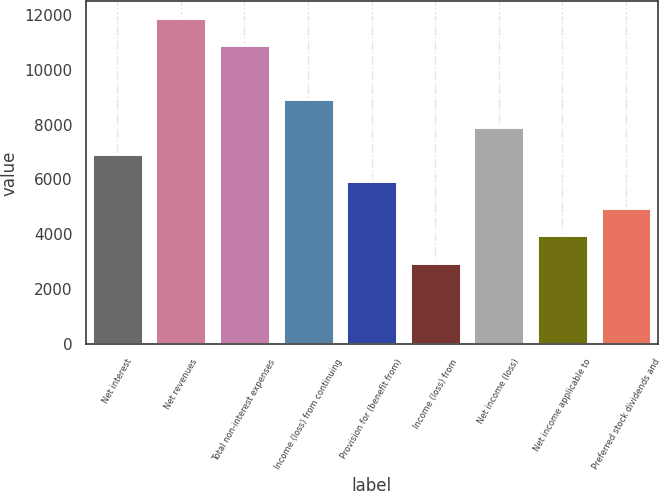Convert chart to OTSL. <chart><loc_0><loc_0><loc_500><loc_500><bar_chart><fcel>Net interest<fcel>Net revenues<fcel>Total non-interest expenses<fcel>Income (loss) from continuing<fcel>Provision for (benefit from)<fcel>Income (loss) from<fcel>Net income (loss)<fcel>Net income applicable to<fcel>Preferred stock dividends and<nl><fcel>6934.93<fcel>11888.4<fcel>10897.7<fcel>8916.31<fcel>5944.24<fcel>2972.17<fcel>7925.62<fcel>3962.86<fcel>4953.55<nl></chart> 